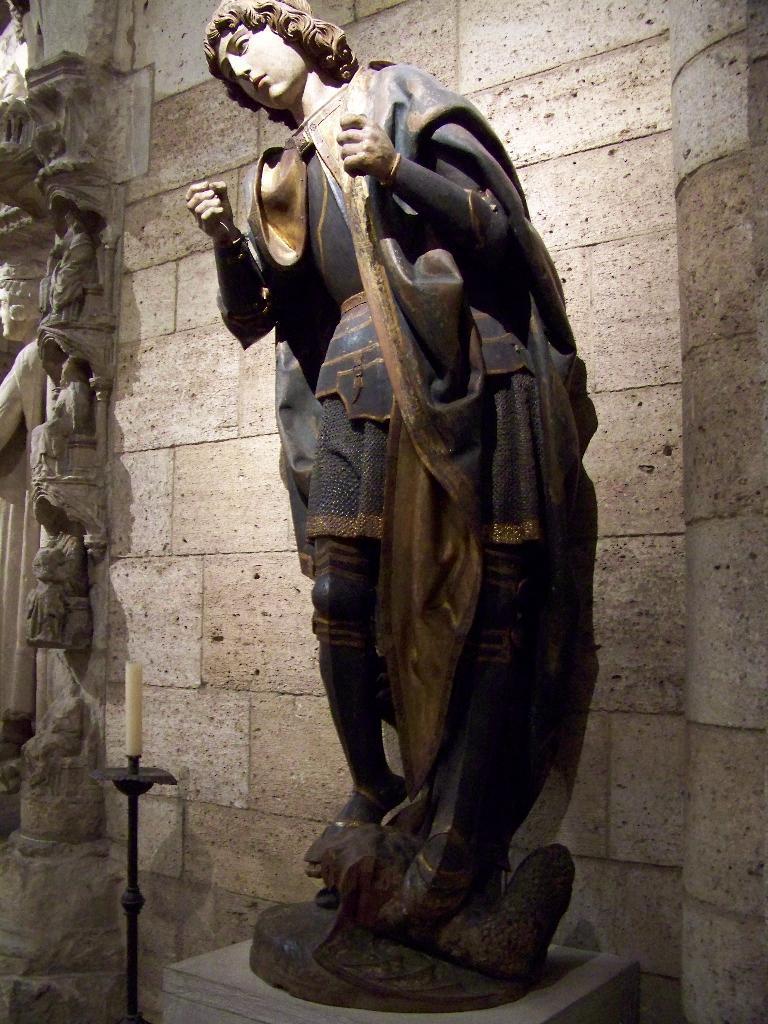How would you summarize this image in a sentence or two? We can see sculpture on platform and candle with stand, behind this sculpture we can see wall and statues. 